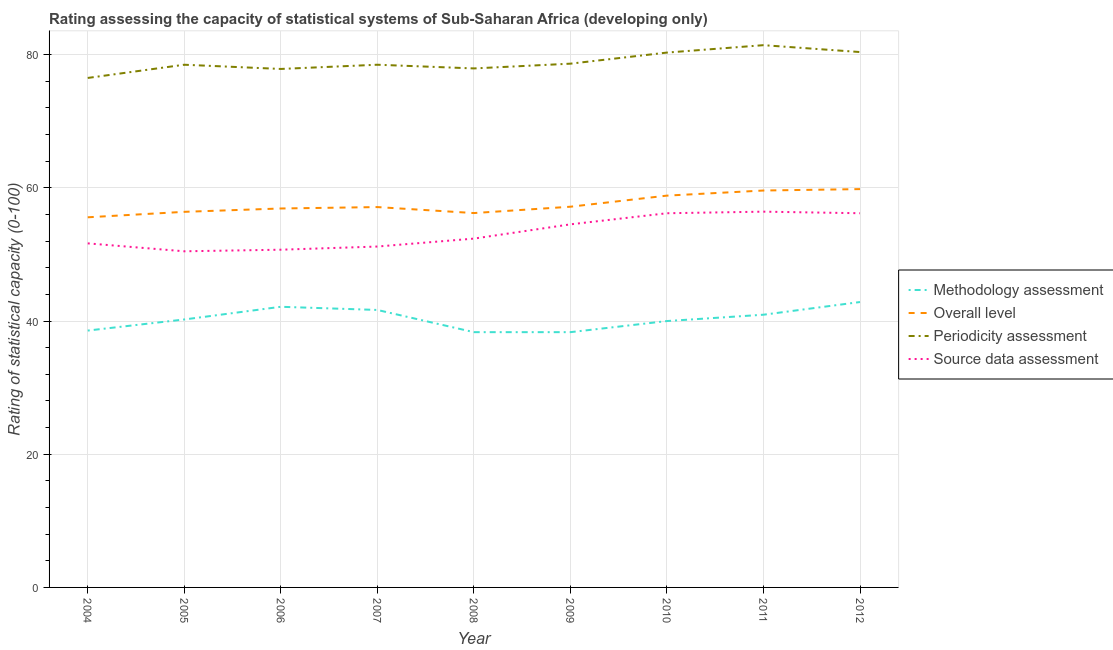How many different coloured lines are there?
Provide a succinct answer. 4. What is the periodicity assessment rating in 2009?
Keep it short and to the point. 78.65. Across all years, what is the maximum periodicity assessment rating?
Offer a very short reply. 81.43. Across all years, what is the minimum periodicity assessment rating?
Give a very brief answer. 76.51. What is the total periodicity assessment rating in the graph?
Your response must be concise. 710.08. What is the difference between the source data assessment rating in 2004 and that in 2009?
Give a very brief answer. -2.86. What is the difference between the overall level rating in 2007 and the methodology assessment rating in 2010?
Make the answer very short. 17.12. What is the average periodicity assessment rating per year?
Your answer should be compact. 78.9. In the year 2007, what is the difference between the methodology assessment rating and overall level rating?
Make the answer very short. -15.45. In how many years, is the overall level rating greater than 72?
Your answer should be very brief. 0. What is the ratio of the periodicity assessment rating in 2005 to that in 2007?
Offer a very short reply. 1. Is the source data assessment rating in 2005 less than that in 2009?
Provide a succinct answer. Yes. Is the difference between the overall level rating in 2004 and 2009 greater than the difference between the methodology assessment rating in 2004 and 2009?
Make the answer very short. No. What is the difference between the highest and the second highest overall level rating?
Offer a very short reply. 0.21. What is the difference between the highest and the lowest overall level rating?
Your response must be concise. 4.23. In how many years, is the overall level rating greater than the average overall level rating taken over all years?
Make the answer very short. 3. Is the sum of the periodicity assessment rating in 2005 and 2009 greater than the maximum overall level rating across all years?
Make the answer very short. Yes. Is it the case that in every year, the sum of the source data assessment rating and periodicity assessment rating is greater than the sum of methodology assessment rating and overall level rating?
Offer a very short reply. Yes. Is it the case that in every year, the sum of the methodology assessment rating and overall level rating is greater than the periodicity assessment rating?
Offer a terse response. Yes. Does the source data assessment rating monotonically increase over the years?
Ensure brevity in your answer.  No. Is the methodology assessment rating strictly less than the source data assessment rating over the years?
Ensure brevity in your answer.  Yes. How many years are there in the graph?
Your response must be concise. 9. What is the difference between two consecutive major ticks on the Y-axis?
Make the answer very short. 20. Does the graph contain any zero values?
Offer a very short reply. No. How many legend labels are there?
Give a very brief answer. 4. How are the legend labels stacked?
Keep it short and to the point. Vertical. What is the title of the graph?
Offer a terse response. Rating assessing the capacity of statistical systems of Sub-Saharan Africa (developing only). What is the label or title of the Y-axis?
Your response must be concise. Rating of statistical capacity (0-100). What is the Rating of statistical capacity (0-100) of Methodology assessment in 2004?
Offer a terse response. 38.57. What is the Rating of statistical capacity (0-100) in Overall level in 2004?
Offer a terse response. 55.58. What is the Rating of statistical capacity (0-100) of Periodicity assessment in 2004?
Provide a short and direct response. 76.51. What is the Rating of statistical capacity (0-100) in Source data assessment in 2004?
Provide a short and direct response. 51.67. What is the Rating of statistical capacity (0-100) of Methodology assessment in 2005?
Your response must be concise. 40.24. What is the Rating of statistical capacity (0-100) in Overall level in 2005?
Your answer should be compact. 56.4. What is the Rating of statistical capacity (0-100) in Periodicity assessment in 2005?
Offer a very short reply. 78.49. What is the Rating of statistical capacity (0-100) in Source data assessment in 2005?
Provide a succinct answer. 50.48. What is the Rating of statistical capacity (0-100) in Methodology assessment in 2006?
Provide a short and direct response. 42.14. What is the Rating of statistical capacity (0-100) of Overall level in 2006?
Make the answer very short. 56.9. What is the Rating of statistical capacity (0-100) of Periodicity assessment in 2006?
Provide a succinct answer. 77.86. What is the Rating of statistical capacity (0-100) in Source data assessment in 2006?
Offer a terse response. 50.71. What is the Rating of statistical capacity (0-100) in Methodology assessment in 2007?
Your answer should be compact. 41.67. What is the Rating of statistical capacity (0-100) of Overall level in 2007?
Provide a succinct answer. 57.12. What is the Rating of statistical capacity (0-100) in Periodicity assessment in 2007?
Your answer should be very brief. 78.49. What is the Rating of statistical capacity (0-100) in Source data assessment in 2007?
Provide a short and direct response. 51.19. What is the Rating of statistical capacity (0-100) of Methodology assessment in 2008?
Ensure brevity in your answer.  38.33. What is the Rating of statistical capacity (0-100) of Overall level in 2008?
Keep it short and to the point. 56.22. What is the Rating of statistical capacity (0-100) of Periodicity assessment in 2008?
Your answer should be compact. 77.94. What is the Rating of statistical capacity (0-100) in Source data assessment in 2008?
Your answer should be compact. 52.38. What is the Rating of statistical capacity (0-100) of Methodology assessment in 2009?
Keep it short and to the point. 38.33. What is the Rating of statistical capacity (0-100) of Overall level in 2009?
Make the answer very short. 57.17. What is the Rating of statistical capacity (0-100) of Periodicity assessment in 2009?
Your answer should be compact. 78.65. What is the Rating of statistical capacity (0-100) of Source data assessment in 2009?
Ensure brevity in your answer.  54.52. What is the Rating of statistical capacity (0-100) of Methodology assessment in 2010?
Provide a succinct answer. 40. What is the Rating of statistical capacity (0-100) of Overall level in 2010?
Provide a succinct answer. 58.84. What is the Rating of statistical capacity (0-100) of Periodicity assessment in 2010?
Provide a short and direct response. 80.32. What is the Rating of statistical capacity (0-100) in Source data assessment in 2010?
Keep it short and to the point. 56.19. What is the Rating of statistical capacity (0-100) of Methodology assessment in 2011?
Offer a very short reply. 40.95. What is the Rating of statistical capacity (0-100) of Overall level in 2011?
Keep it short and to the point. 59.6. What is the Rating of statistical capacity (0-100) in Periodicity assessment in 2011?
Give a very brief answer. 81.43. What is the Rating of statistical capacity (0-100) of Source data assessment in 2011?
Your response must be concise. 56.43. What is the Rating of statistical capacity (0-100) in Methodology assessment in 2012?
Offer a terse response. 42.86. What is the Rating of statistical capacity (0-100) of Overall level in 2012?
Provide a short and direct response. 59.81. What is the Rating of statistical capacity (0-100) of Periodicity assessment in 2012?
Keep it short and to the point. 80.4. What is the Rating of statistical capacity (0-100) in Source data assessment in 2012?
Offer a very short reply. 56.19. Across all years, what is the maximum Rating of statistical capacity (0-100) of Methodology assessment?
Offer a very short reply. 42.86. Across all years, what is the maximum Rating of statistical capacity (0-100) of Overall level?
Offer a terse response. 59.81. Across all years, what is the maximum Rating of statistical capacity (0-100) of Periodicity assessment?
Offer a terse response. 81.43. Across all years, what is the maximum Rating of statistical capacity (0-100) of Source data assessment?
Give a very brief answer. 56.43. Across all years, what is the minimum Rating of statistical capacity (0-100) in Methodology assessment?
Make the answer very short. 38.33. Across all years, what is the minimum Rating of statistical capacity (0-100) in Overall level?
Your answer should be very brief. 55.58. Across all years, what is the minimum Rating of statistical capacity (0-100) in Periodicity assessment?
Your answer should be compact. 76.51. Across all years, what is the minimum Rating of statistical capacity (0-100) in Source data assessment?
Your answer should be compact. 50.48. What is the total Rating of statistical capacity (0-100) in Methodology assessment in the graph?
Offer a terse response. 363.1. What is the total Rating of statistical capacity (0-100) in Overall level in the graph?
Provide a short and direct response. 517.65. What is the total Rating of statistical capacity (0-100) of Periodicity assessment in the graph?
Your answer should be compact. 710.08. What is the total Rating of statistical capacity (0-100) in Source data assessment in the graph?
Your response must be concise. 479.76. What is the difference between the Rating of statistical capacity (0-100) in Methodology assessment in 2004 and that in 2005?
Ensure brevity in your answer.  -1.67. What is the difference between the Rating of statistical capacity (0-100) of Overall level in 2004 and that in 2005?
Provide a short and direct response. -0.82. What is the difference between the Rating of statistical capacity (0-100) of Periodicity assessment in 2004 and that in 2005?
Provide a succinct answer. -1.98. What is the difference between the Rating of statistical capacity (0-100) in Source data assessment in 2004 and that in 2005?
Make the answer very short. 1.19. What is the difference between the Rating of statistical capacity (0-100) in Methodology assessment in 2004 and that in 2006?
Your answer should be very brief. -3.57. What is the difference between the Rating of statistical capacity (0-100) in Overall level in 2004 and that in 2006?
Your answer should be very brief. -1.32. What is the difference between the Rating of statistical capacity (0-100) in Periodicity assessment in 2004 and that in 2006?
Make the answer very short. -1.35. What is the difference between the Rating of statistical capacity (0-100) in Source data assessment in 2004 and that in 2006?
Your answer should be very brief. 0.95. What is the difference between the Rating of statistical capacity (0-100) in Methodology assessment in 2004 and that in 2007?
Give a very brief answer. -3.1. What is the difference between the Rating of statistical capacity (0-100) of Overall level in 2004 and that in 2007?
Give a very brief answer. -1.53. What is the difference between the Rating of statistical capacity (0-100) in Periodicity assessment in 2004 and that in 2007?
Provide a succinct answer. -1.98. What is the difference between the Rating of statistical capacity (0-100) of Source data assessment in 2004 and that in 2007?
Ensure brevity in your answer.  0.48. What is the difference between the Rating of statistical capacity (0-100) in Methodology assessment in 2004 and that in 2008?
Keep it short and to the point. 0.24. What is the difference between the Rating of statistical capacity (0-100) of Overall level in 2004 and that in 2008?
Make the answer very short. -0.63. What is the difference between the Rating of statistical capacity (0-100) in Periodicity assessment in 2004 and that in 2008?
Offer a very short reply. -1.43. What is the difference between the Rating of statistical capacity (0-100) in Source data assessment in 2004 and that in 2008?
Offer a terse response. -0.71. What is the difference between the Rating of statistical capacity (0-100) in Methodology assessment in 2004 and that in 2009?
Make the answer very short. 0.24. What is the difference between the Rating of statistical capacity (0-100) of Overall level in 2004 and that in 2009?
Your answer should be compact. -1.59. What is the difference between the Rating of statistical capacity (0-100) of Periodicity assessment in 2004 and that in 2009?
Your response must be concise. -2.14. What is the difference between the Rating of statistical capacity (0-100) of Source data assessment in 2004 and that in 2009?
Your answer should be compact. -2.86. What is the difference between the Rating of statistical capacity (0-100) in Methodology assessment in 2004 and that in 2010?
Make the answer very short. -1.43. What is the difference between the Rating of statistical capacity (0-100) in Overall level in 2004 and that in 2010?
Ensure brevity in your answer.  -3.25. What is the difference between the Rating of statistical capacity (0-100) in Periodicity assessment in 2004 and that in 2010?
Your answer should be very brief. -3.81. What is the difference between the Rating of statistical capacity (0-100) of Source data assessment in 2004 and that in 2010?
Offer a very short reply. -4.52. What is the difference between the Rating of statistical capacity (0-100) of Methodology assessment in 2004 and that in 2011?
Keep it short and to the point. -2.38. What is the difference between the Rating of statistical capacity (0-100) in Overall level in 2004 and that in 2011?
Ensure brevity in your answer.  -4.02. What is the difference between the Rating of statistical capacity (0-100) in Periodicity assessment in 2004 and that in 2011?
Your answer should be very brief. -4.92. What is the difference between the Rating of statistical capacity (0-100) in Source data assessment in 2004 and that in 2011?
Your answer should be compact. -4.76. What is the difference between the Rating of statistical capacity (0-100) of Methodology assessment in 2004 and that in 2012?
Provide a short and direct response. -4.29. What is the difference between the Rating of statistical capacity (0-100) of Overall level in 2004 and that in 2012?
Keep it short and to the point. -4.23. What is the difference between the Rating of statistical capacity (0-100) of Periodicity assessment in 2004 and that in 2012?
Your answer should be very brief. -3.89. What is the difference between the Rating of statistical capacity (0-100) of Source data assessment in 2004 and that in 2012?
Offer a very short reply. -4.52. What is the difference between the Rating of statistical capacity (0-100) in Methodology assessment in 2005 and that in 2006?
Ensure brevity in your answer.  -1.9. What is the difference between the Rating of statistical capacity (0-100) in Overall level in 2005 and that in 2006?
Your answer should be compact. -0.5. What is the difference between the Rating of statistical capacity (0-100) of Periodicity assessment in 2005 and that in 2006?
Provide a short and direct response. 0.63. What is the difference between the Rating of statistical capacity (0-100) of Source data assessment in 2005 and that in 2006?
Provide a short and direct response. -0.24. What is the difference between the Rating of statistical capacity (0-100) of Methodology assessment in 2005 and that in 2007?
Your answer should be very brief. -1.43. What is the difference between the Rating of statistical capacity (0-100) of Overall level in 2005 and that in 2007?
Your answer should be compact. -0.71. What is the difference between the Rating of statistical capacity (0-100) in Source data assessment in 2005 and that in 2007?
Ensure brevity in your answer.  -0.71. What is the difference between the Rating of statistical capacity (0-100) of Methodology assessment in 2005 and that in 2008?
Provide a short and direct response. 1.9. What is the difference between the Rating of statistical capacity (0-100) in Overall level in 2005 and that in 2008?
Make the answer very short. 0.19. What is the difference between the Rating of statistical capacity (0-100) of Periodicity assessment in 2005 and that in 2008?
Offer a terse response. 0.56. What is the difference between the Rating of statistical capacity (0-100) in Source data assessment in 2005 and that in 2008?
Your answer should be very brief. -1.9. What is the difference between the Rating of statistical capacity (0-100) in Methodology assessment in 2005 and that in 2009?
Provide a succinct answer. 1.9. What is the difference between the Rating of statistical capacity (0-100) of Overall level in 2005 and that in 2009?
Provide a succinct answer. -0.77. What is the difference between the Rating of statistical capacity (0-100) of Periodicity assessment in 2005 and that in 2009?
Ensure brevity in your answer.  -0.16. What is the difference between the Rating of statistical capacity (0-100) in Source data assessment in 2005 and that in 2009?
Your answer should be compact. -4.05. What is the difference between the Rating of statistical capacity (0-100) of Methodology assessment in 2005 and that in 2010?
Your answer should be very brief. 0.24. What is the difference between the Rating of statistical capacity (0-100) of Overall level in 2005 and that in 2010?
Your answer should be very brief. -2.43. What is the difference between the Rating of statistical capacity (0-100) in Periodicity assessment in 2005 and that in 2010?
Offer a very short reply. -1.83. What is the difference between the Rating of statistical capacity (0-100) in Source data assessment in 2005 and that in 2010?
Provide a short and direct response. -5.71. What is the difference between the Rating of statistical capacity (0-100) in Methodology assessment in 2005 and that in 2011?
Your answer should be very brief. -0.71. What is the difference between the Rating of statistical capacity (0-100) in Overall level in 2005 and that in 2011?
Offer a very short reply. -3.2. What is the difference between the Rating of statistical capacity (0-100) of Periodicity assessment in 2005 and that in 2011?
Give a very brief answer. -2.94. What is the difference between the Rating of statistical capacity (0-100) in Source data assessment in 2005 and that in 2011?
Provide a short and direct response. -5.95. What is the difference between the Rating of statistical capacity (0-100) of Methodology assessment in 2005 and that in 2012?
Provide a succinct answer. -2.62. What is the difference between the Rating of statistical capacity (0-100) of Overall level in 2005 and that in 2012?
Your response must be concise. -3.41. What is the difference between the Rating of statistical capacity (0-100) in Periodicity assessment in 2005 and that in 2012?
Give a very brief answer. -1.9. What is the difference between the Rating of statistical capacity (0-100) of Source data assessment in 2005 and that in 2012?
Give a very brief answer. -5.71. What is the difference between the Rating of statistical capacity (0-100) in Methodology assessment in 2006 and that in 2007?
Keep it short and to the point. 0.48. What is the difference between the Rating of statistical capacity (0-100) in Overall level in 2006 and that in 2007?
Your answer should be very brief. -0.21. What is the difference between the Rating of statistical capacity (0-100) in Periodicity assessment in 2006 and that in 2007?
Provide a succinct answer. -0.63. What is the difference between the Rating of statistical capacity (0-100) in Source data assessment in 2006 and that in 2007?
Your response must be concise. -0.48. What is the difference between the Rating of statistical capacity (0-100) in Methodology assessment in 2006 and that in 2008?
Your answer should be very brief. 3.81. What is the difference between the Rating of statistical capacity (0-100) of Overall level in 2006 and that in 2008?
Give a very brief answer. 0.69. What is the difference between the Rating of statistical capacity (0-100) in Periodicity assessment in 2006 and that in 2008?
Make the answer very short. -0.08. What is the difference between the Rating of statistical capacity (0-100) in Source data assessment in 2006 and that in 2008?
Offer a very short reply. -1.67. What is the difference between the Rating of statistical capacity (0-100) in Methodology assessment in 2006 and that in 2009?
Provide a short and direct response. 3.81. What is the difference between the Rating of statistical capacity (0-100) in Overall level in 2006 and that in 2009?
Your answer should be compact. -0.26. What is the difference between the Rating of statistical capacity (0-100) in Periodicity assessment in 2006 and that in 2009?
Make the answer very short. -0.79. What is the difference between the Rating of statistical capacity (0-100) in Source data assessment in 2006 and that in 2009?
Your response must be concise. -3.81. What is the difference between the Rating of statistical capacity (0-100) in Methodology assessment in 2006 and that in 2010?
Give a very brief answer. 2.14. What is the difference between the Rating of statistical capacity (0-100) of Overall level in 2006 and that in 2010?
Offer a very short reply. -1.93. What is the difference between the Rating of statistical capacity (0-100) in Periodicity assessment in 2006 and that in 2010?
Keep it short and to the point. -2.46. What is the difference between the Rating of statistical capacity (0-100) of Source data assessment in 2006 and that in 2010?
Offer a very short reply. -5.48. What is the difference between the Rating of statistical capacity (0-100) of Methodology assessment in 2006 and that in 2011?
Offer a terse response. 1.19. What is the difference between the Rating of statistical capacity (0-100) in Overall level in 2006 and that in 2011?
Offer a very short reply. -2.7. What is the difference between the Rating of statistical capacity (0-100) in Periodicity assessment in 2006 and that in 2011?
Ensure brevity in your answer.  -3.57. What is the difference between the Rating of statistical capacity (0-100) in Source data assessment in 2006 and that in 2011?
Make the answer very short. -5.71. What is the difference between the Rating of statistical capacity (0-100) in Methodology assessment in 2006 and that in 2012?
Your answer should be very brief. -0.71. What is the difference between the Rating of statistical capacity (0-100) of Overall level in 2006 and that in 2012?
Your answer should be very brief. -2.91. What is the difference between the Rating of statistical capacity (0-100) of Periodicity assessment in 2006 and that in 2012?
Offer a terse response. -2.54. What is the difference between the Rating of statistical capacity (0-100) of Source data assessment in 2006 and that in 2012?
Offer a very short reply. -5.48. What is the difference between the Rating of statistical capacity (0-100) of Overall level in 2007 and that in 2008?
Your answer should be very brief. 0.9. What is the difference between the Rating of statistical capacity (0-100) in Periodicity assessment in 2007 and that in 2008?
Offer a very short reply. 0.56. What is the difference between the Rating of statistical capacity (0-100) of Source data assessment in 2007 and that in 2008?
Your response must be concise. -1.19. What is the difference between the Rating of statistical capacity (0-100) in Methodology assessment in 2007 and that in 2009?
Your answer should be compact. 3.33. What is the difference between the Rating of statistical capacity (0-100) of Overall level in 2007 and that in 2009?
Make the answer very short. -0.05. What is the difference between the Rating of statistical capacity (0-100) of Periodicity assessment in 2007 and that in 2009?
Offer a terse response. -0.16. What is the difference between the Rating of statistical capacity (0-100) in Methodology assessment in 2007 and that in 2010?
Provide a short and direct response. 1.67. What is the difference between the Rating of statistical capacity (0-100) of Overall level in 2007 and that in 2010?
Keep it short and to the point. -1.72. What is the difference between the Rating of statistical capacity (0-100) of Periodicity assessment in 2007 and that in 2010?
Your answer should be very brief. -1.83. What is the difference between the Rating of statistical capacity (0-100) in Source data assessment in 2007 and that in 2010?
Keep it short and to the point. -5. What is the difference between the Rating of statistical capacity (0-100) of Overall level in 2007 and that in 2011?
Give a very brief answer. -2.49. What is the difference between the Rating of statistical capacity (0-100) in Periodicity assessment in 2007 and that in 2011?
Your answer should be very brief. -2.94. What is the difference between the Rating of statistical capacity (0-100) of Source data assessment in 2007 and that in 2011?
Keep it short and to the point. -5.24. What is the difference between the Rating of statistical capacity (0-100) of Methodology assessment in 2007 and that in 2012?
Your response must be concise. -1.19. What is the difference between the Rating of statistical capacity (0-100) in Overall level in 2007 and that in 2012?
Your response must be concise. -2.7. What is the difference between the Rating of statistical capacity (0-100) of Periodicity assessment in 2007 and that in 2012?
Offer a terse response. -1.9. What is the difference between the Rating of statistical capacity (0-100) in Source data assessment in 2007 and that in 2012?
Ensure brevity in your answer.  -5. What is the difference between the Rating of statistical capacity (0-100) in Methodology assessment in 2008 and that in 2009?
Offer a very short reply. 0. What is the difference between the Rating of statistical capacity (0-100) in Overall level in 2008 and that in 2009?
Your response must be concise. -0.95. What is the difference between the Rating of statistical capacity (0-100) of Periodicity assessment in 2008 and that in 2009?
Give a very brief answer. -0.71. What is the difference between the Rating of statistical capacity (0-100) in Source data assessment in 2008 and that in 2009?
Keep it short and to the point. -2.14. What is the difference between the Rating of statistical capacity (0-100) of Methodology assessment in 2008 and that in 2010?
Provide a short and direct response. -1.67. What is the difference between the Rating of statistical capacity (0-100) in Overall level in 2008 and that in 2010?
Offer a terse response. -2.62. What is the difference between the Rating of statistical capacity (0-100) in Periodicity assessment in 2008 and that in 2010?
Offer a terse response. -2.38. What is the difference between the Rating of statistical capacity (0-100) of Source data assessment in 2008 and that in 2010?
Make the answer very short. -3.81. What is the difference between the Rating of statistical capacity (0-100) of Methodology assessment in 2008 and that in 2011?
Your response must be concise. -2.62. What is the difference between the Rating of statistical capacity (0-100) in Overall level in 2008 and that in 2011?
Ensure brevity in your answer.  -3.39. What is the difference between the Rating of statistical capacity (0-100) in Periodicity assessment in 2008 and that in 2011?
Your response must be concise. -3.49. What is the difference between the Rating of statistical capacity (0-100) of Source data assessment in 2008 and that in 2011?
Give a very brief answer. -4.05. What is the difference between the Rating of statistical capacity (0-100) in Methodology assessment in 2008 and that in 2012?
Offer a terse response. -4.52. What is the difference between the Rating of statistical capacity (0-100) in Overall level in 2008 and that in 2012?
Your response must be concise. -3.6. What is the difference between the Rating of statistical capacity (0-100) of Periodicity assessment in 2008 and that in 2012?
Ensure brevity in your answer.  -2.46. What is the difference between the Rating of statistical capacity (0-100) in Source data assessment in 2008 and that in 2012?
Your response must be concise. -3.81. What is the difference between the Rating of statistical capacity (0-100) of Methodology assessment in 2009 and that in 2010?
Your answer should be compact. -1.67. What is the difference between the Rating of statistical capacity (0-100) in Overall level in 2009 and that in 2010?
Ensure brevity in your answer.  -1.67. What is the difference between the Rating of statistical capacity (0-100) in Periodicity assessment in 2009 and that in 2010?
Ensure brevity in your answer.  -1.67. What is the difference between the Rating of statistical capacity (0-100) of Source data assessment in 2009 and that in 2010?
Your answer should be very brief. -1.67. What is the difference between the Rating of statistical capacity (0-100) of Methodology assessment in 2009 and that in 2011?
Ensure brevity in your answer.  -2.62. What is the difference between the Rating of statistical capacity (0-100) of Overall level in 2009 and that in 2011?
Keep it short and to the point. -2.43. What is the difference between the Rating of statistical capacity (0-100) in Periodicity assessment in 2009 and that in 2011?
Offer a terse response. -2.78. What is the difference between the Rating of statistical capacity (0-100) of Source data assessment in 2009 and that in 2011?
Provide a succinct answer. -1.9. What is the difference between the Rating of statistical capacity (0-100) of Methodology assessment in 2009 and that in 2012?
Ensure brevity in your answer.  -4.52. What is the difference between the Rating of statistical capacity (0-100) of Overall level in 2009 and that in 2012?
Keep it short and to the point. -2.65. What is the difference between the Rating of statistical capacity (0-100) of Periodicity assessment in 2009 and that in 2012?
Provide a succinct answer. -1.75. What is the difference between the Rating of statistical capacity (0-100) of Source data assessment in 2009 and that in 2012?
Your answer should be compact. -1.67. What is the difference between the Rating of statistical capacity (0-100) of Methodology assessment in 2010 and that in 2011?
Give a very brief answer. -0.95. What is the difference between the Rating of statistical capacity (0-100) in Overall level in 2010 and that in 2011?
Offer a very short reply. -0.77. What is the difference between the Rating of statistical capacity (0-100) in Periodicity assessment in 2010 and that in 2011?
Your answer should be very brief. -1.11. What is the difference between the Rating of statistical capacity (0-100) of Source data assessment in 2010 and that in 2011?
Provide a succinct answer. -0.24. What is the difference between the Rating of statistical capacity (0-100) of Methodology assessment in 2010 and that in 2012?
Make the answer very short. -2.86. What is the difference between the Rating of statistical capacity (0-100) in Overall level in 2010 and that in 2012?
Your response must be concise. -0.98. What is the difference between the Rating of statistical capacity (0-100) in Periodicity assessment in 2010 and that in 2012?
Provide a succinct answer. -0.08. What is the difference between the Rating of statistical capacity (0-100) in Methodology assessment in 2011 and that in 2012?
Your response must be concise. -1.9. What is the difference between the Rating of statistical capacity (0-100) in Overall level in 2011 and that in 2012?
Provide a short and direct response. -0.21. What is the difference between the Rating of statistical capacity (0-100) in Periodicity assessment in 2011 and that in 2012?
Your answer should be compact. 1.03. What is the difference between the Rating of statistical capacity (0-100) of Source data assessment in 2011 and that in 2012?
Offer a terse response. 0.24. What is the difference between the Rating of statistical capacity (0-100) of Methodology assessment in 2004 and the Rating of statistical capacity (0-100) of Overall level in 2005?
Provide a succinct answer. -17.83. What is the difference between the Rating of statistical capacity (0-100) of Methodology assessment in 2004 and the Rating of statistical capacity (0-100) of Periodicity assessment in 2005?
Your answer should be very brief. -39.92. What is the difference between the Rating of statistical capacity (0-100) of Methodology assessment in 2004 and the Rating of statistical capacity (0-100) of Source data assessment in 2005?
Ensure brevity in your answer.  -11.9. What is the difference between the Rating of statistical capacity (0-100) in Overall level in 2004 and the Rating of statistical capacity (0-100) in Periodicity assessment in 2005?
Offer a very short reply. -22.91. What is the difference between the Rating of statistical capacity (0-100) of Overall level in 2004 and the Rating of statistical capacity (0-100) of Source data assessment in 2005?
Provide a succinct answer. 5.11. What is the difference between the Rating of statistical capacity (0-100) in Periodicity assessment in 2004 and the Rating of statistical capacity (0-100) in Source data assessment in 2005?
Offer a very short reply. 26.03. What is the difference between the Rating of statistical capacity (0-100) in Methodology assessment in 2004 and the Rating of statistical capacity (0-100) in Overall level in 2006?
Make the answer very short. -18.33. What is the difference between the Rating of statistical capacity (0-100) in Methodology assessment in 2004 and the Rating of statistical capacity (0-100) in Periodicity assessment in 2006?
Keep it short and to the point. -39.29. What is the difference between the Rating of statistical capacity (0-100) of Methodology assessment in 2004 and the Rating of statistical capacity (0-100) of Source data assessment in 2006?
Offer a terse response. -12.14. What is the difference between the Rating of statistical capacity (0-100) of Overall level in 2004 and the Rating of statistical capacity (0-100) of Periodicity assessment in 2006?
Keep it short and to the point. -22.28. What is the difference between the Rating of statistical capacity (0-100) in Overall level in 2004 and the Rating of statistical capacity (0-100) in Source data assessment in 2006?
Keep it short and to the point. 4.87. What is the difference between the Rating of statistical capacity (0-100) of Periodicity assessment in 2004 and the Rating of statistical capacity (0-100) of Source data assessment in 2006?
Keep it short and to the point. 25.79. What is the difference between the Rating of statistical capacity (0-100) in Methodology assessment in 2004 and the Rating of statistical capacity (0-100) in Overall level in 2007?
Make the answer very short. -18.55. What is the difference between the Rating of statistical capacity (0-100) of Methodology assessment in 2004 and the Rating of statistical capacity (0-100) of Periodicity assessment in 2007?
Keep it short and to the point. -39.92. What is the difference between the Rating of statistical capacity (0-100) in Methodology assessment in 2004 and the Rating of statistical capacity (0-100) in Source data assessment in 2007?
Ensure brevity in your answer.  -12.62. What is the difference between the Rating of statistical capacity (0-100) of Overall level in 2004 and the Rating of statistical capacity (0-100) of Periodicity assessment in 2007?
Your response must be concise. -22.91. What is the difference between the Rating of statistical capacity (0-100) in Overall level in 2004 and the Rating of statistical capacity (0-100) in Source data assessment in 2007?
Your answer should be compact. 4.39. What is the difference between the Rating of statistical capacity (0-100) of Periodicity assessment in 2004 and the Rating of statistical capacity (0-100) of Source data assessment in 2007?
Provide a succinct answer. 25.32. What is the difference between the Rating of statistical capacity (0-100) in Methodology assessment in 2004 and the Rating of statistical capacity (0-100) in Overall level in 2008?
Give a very brief answer. -17.65. What is the difference between the Rating of statistical capacity (0-100) of Methodology assessment in 2004 and the Rating of statistical capacity (0-100) of Periodicity assessment in 2008?
Your response must be concise. -39.37. What is the difference between the Rating of statistical capacity (0-100) in Methodology assessment in 2004 and the Rating of statistical capacity (0-100) in Source data assessment in 2008?
Offer a terse response. -13.81. What is the difference between the Rating of statistical capacity (0-100) of Overall level in 2004 and the Rating of statistical capacity (0-100) of Periodicity assessment in 2008?
Your response must be concise. -22.35. What is the difference between the Rating of statistical capacity (0-100) of Overall level in 2004 and the Rating of statistical capacity (0-100) of Source data assessment in 2008?
Provide a short and direct response. 3.2. What is the difference between the Rating of statistical capacity (0-100) of Periodicity assessment in 2004 and the Rating of statistical capacity (0-100) of Source data assessment in 2008?
Offer a very short reply. 24.13. What is the difference between the Rating of statistical capacity (0-100) of Methodology assessment in 2004 and the Rating of statistical capacity (0-100) of Overall level in 2009?
Keep it short and to the point. -18.6. What is the difference between the Rating of statistical capacity (0-100) in Methodology assessment in 2004 and the Rating of statistical capacity (0-100) in Periodicity assessment in 2009?
Your answer should be very brief. -40.08. What is the difference between the Rating of statistical capacity (0-100) of Methodology assessment in 2004 and the Rating of statistical capacity (0-100) of Source data assessment in 2009?
Give a very brief answer. -15.95. What is the difference between the Rating of statistical capacity (0-100) of Overall level in 2004 and the Rating of statistical capacity (0-100) of Periodicity assessment in 2009?
Offer a very short reply. -23.07. What is the difference between the Rating of statistical capacity (0-100) in Overall level in 2004 and the Rating of statistical capacity (0-100) in Source data assessment in 2009?
Offer a very short reply. 1.06. What is the difference between the Rating of statistical capacity (0-100) in Periodicity assessment in 2004 and the Rating of statistical capacity (0-100) in Source data assessment in 2009?
Provide a succinct answer. 21.98. What is the difference between the Rating of statistical capacity (0-100) of Methodology assessment in 2004 and the Rating of statistical capacity (0-100) of Overall level in 2010?
Your response must be concise. -20.26. What is the difference between the Rating of statistical capacity (0-100) of Methodology assessment in 2004 and the Rating of statistical capacity (0-100) of Periodicity assessment in 2010?
Offer a terse response. -41.75. What is the difference between the Rating of statistical capacity (0-100) in Methodology assessment in 2004 and the Rating of statistical capacity (0-100) in Source data assessment in 2010?
Make the answer very short. -17.62. What is the difference between the Rating of statistical capacity (0-100) of Overall level in 2004 and the Rating of statistical capacity (0-100) of Periodicity assessment in 2010?
Keep it short and to the point. -24.74. What is the difference between the Rating of statistical capacity (0-100) of Overall level in 2004 and the Rating of statistical capacity (0-100) of Source data assessment in 2010?
Offer a very short reply. -0.61. What is the difference between the Rating of statistical capacity (0-100) of Periodicity assessment in 2004 and the Rating of statistical capacity (0-100) of Source data assessment in 2010?
Your answer should be compact. 20.32. What is the difference between the Rating of statistical capacity (0-100) in Methodology assessment in 2004 and the Rating of statistical capacity (0-100) in Overall level in 2011?
Make the answer very short. -21.03. What is the difference between the Rating of statistical capacity (0-100) in Methodology assessment in 2004 and the Rating of statistical capacity (0-100) in Periodicity assessment in 2011?
Your answer should be compact. -42.86. What is the difference between the Rating of statistical capacity (0-100) in Methodology assessment in 2004 and the Rating of statistical capacity (0-100) in Source data assessment in 2011?
Provide a succinct answer. -17.86. What is the difference between the Rating of statistical capacity (0-100) of Overall level in 2004 and the Rating of statistical capacity (0-100) of Periodicity assessment in 2011?
Your answer should be compact. -25.85. What is the difference between the Rating of statistical capacity (0-100) in Overall level in 2004 and the Rating of statistical capacity (0-100) in Source data assessment in 2011?
Offer a terse response. -0.85. What is the difference between the Rating of statistical capacity (0-100) of Periodicity assessment in 2004 and the Rating of statistical capacity (0-100) of Source data assessment in 2011?
Your response must be concise. 20.08. What is the difference between the Rating of statistical capacity (0-100) of Methodology assessment in 2004 and the Rating of statistical capacity (0-100) of Overall level in 2012?
Your response must be concise. -21.24. What is the difference between the Rating of statistical capacity (0-100) of Methodology assessment in 2004 and the Rating of statistical capacity (0-100) of Periodicity assessment in 2012?
Provide a short and direct response. -41.83. What is the difference between the Rating of statistical capacity (0-100) of Methodology assessment in 2004 and the Rating of statistical capacity (0-100) of Source data assessment in 2012?
Ensure brevity in your answer.  -17.62. What is the difference between the Rating of statistical capacity (0-100) in Overall level in 2004 and the Rating of statistical capacity (0-100) in Periodicity assessment in 2012?
Provide a succinct answer. -24.81. What is the difference between the Rating of statistical capacity (0-100) of Overall level in 2004 and the Rating of statistical capacity (0-100) of Source data assessment in 2012?
Provide a short and direct response. -0.61. What is the difference between the Rating of statistical capacity (0-100) of Periodicity assessment in 2004 and the Rating of statistical capacity (0-100) of Source data assessment in 2012?
Give a very brief answer. 20.32. What is the difference between the Rating of statistical capacity (0-100) in Methodology assessment in 2005 and the Rating of statistical capacity (0-100) in Overall level in 2006?
Provide a succinct answer. -16.67. What is the difference between the Rating of statistical capacity (0-100) of Methodology assessment in 2005 and the Rating of statistical capacity (0-100) of Periodicity assessment in 2006?
Your response must be concise. -37.62. What is the difference between the Rating of statistical capacity (0-100) in Methodology assessment in 2005 and the Rating of statistical capacity (0-100) in Source data assessment in 2006?
Offer a very short reply. -10.48. What is the difference between the Rating of statistical capacity (0-100) in Overall level in 2005 and the Rating of statistical capacity (0-100) in Periodicity assessment in 2006?
Provide a succinct answer. -21.45. What is the difference between the Rating of statistical capacity (0-100) of Overall level in 2005 and the Rating of statistical capacity (0-100) of Source data assessment in 2006?
Ensure brevity in your answer.  5.69. What is the difference between the Rating of statistical capacity (0-100) in Periodicity assessment in 2005 and the Rating of statistical capacity (0-100) in Source data assessment in 2006?
Offer a terse response. 27.78. What is the difference between the Rating of statistical capacity (0-100) in Methodology assessment in 2005 and the Rating of statistical capacity (0-100) in Overall level in 2007?
Provide a succinct answer. -16.88. What is the difference between the Rating of statistical capacity (0-100) in Methodology assessment in 2005 and the Rating of statistical capacity (0-100) in Periodicity assessment in 2007?
Give a very brief answer. -38.25. What is the difference between the Rating of statistical capacity (0-100) of Methodology assessment in 2005 and the Rating of statistical capacity (0-100) of Source data assessment in 2007?
Your response must be concise. -10.95. What is the difference between the Rating of statistical capacity (0-100) in Overall level in 2005 and the Rating of statistical capacity (0-100) in Periodicity assessment in 2007?
Provide a short and direct response. -22.09. What is the difference between the Rating of statistical capacity (0-100) in Overall level in 2005 and the Rating of statistical capacity (0-100) in Source data assessment in 2007?
Provide a succinct answer. 5.21. What is the difference between the Rating of statistical capacity (0-100) of Periodicity assessment in 2005 and the Rating of statistical capacity (0-100) of Source data assessment in 2007?
Give a very brief answer. 27.3. What is the difference between the Rating of statistical capacity (0-100) of Methodology assessment in 2005 and the Rating of statistical capacity (0-100) of Overall level in 2008?
Your answer should be very brief. -15.98. What is the difference between the Rating of statistical capacity (0-100) in Methodology assessment in 2005 and the Rating of statistical capacity (0-100) in Periodicity assessment in 2008?
Offer a terse response. -37.7. What is the difference between the Rating of statistical capacity (0-100) of Methodology assessment in 2005 and the Rating of statistical capacity (0-100) of Source data assessment in 2008?
Keep it short and to the point. -12.14. What is the difference between the Rating of statistical capacity (0-100) of Overall level in 2005 and the Rating of statistical capacity (0-100) of Periodicity assessment in 2008?
Your response must be concise. -21.53. What is the difference between the Rating of statistical capacity (0-100) in Overall level in 2005 and the Rating of statistical capacity (0-100) in Source data assessment in 2008?
Your answer should be very brief. 4.02. What is the difference between the Rating of statistical capacity (0-100) of Periodicity assessment in 2005 and the Rating of statistical capacity (0-100) of Source data assessment in 2008?
Keep it short and to the point. 26.11. What is the difference between the Rating of statistical capacity (0-100) in Methodology assessment in 2005 and the Rating of statistical capacity (0-100) in Overall level in 2009?
Your response must be concise. -16.93. What is the difference between the Rating of statistical capacity (0-100) of Methodology assessment in 2005 and the Rating of statistical capacity (0-100) of Periodicity assessment in 2009?
Offer a terse response. -38.41. What is the difference between the Rating of statistical capacity (0-100) in Methodology assessment in 2005 and the Rating of statistical capacity (0-100) in Source data assessment in 2009?
Keep it short and to the point. -14.29. What is the difference between the Rating of statistical capacity (0-100) of Overall level in 2005 and the Rating of statistical capacity (0-100) of Periodicity assessment in 2009?
Keep it short and to the point. -22.25. What is the difference between the Rating of statistical capacity (0-100) of Overall level in 2005 and the Rating of statistical capacity (0-100) of Source data assessment in 2009?
Give a very brief answer. 1.88. What is the difference between the Rating of statistical capacity (0-100) in Periodicity assessment in 2005 and the Rating of statistical capacity (0-100) in Source data assessment in 2009?
Provide a short and direct response. 23.97. What is the difference between the Rating of statistical capacity (0-100) of Methodology assessment in 2005 and the Rating of statistical capacity (0-100) of Overall level in 2010?
Ensure brevity in your answer.  -18.6. What is the difference between the Rating of statistical capacity (0-100) of Methodology assessment in 2005 and the Rating of statistical capacity (0-100) of Periodicity assessment in 2010?
Ensure brevity in your answer.  -40.08. What is the difference between the Rating of statistical capacity (0-100) in Methodology assessment in 2005 and the Rating of statistical capacity (0-100) in Source data assessment in 2010?
Your answer should be very brief. -15.95. What is the difference between the Rating of statistical capacity (0-100) in Overall level in 2005 and the Rating of statistical capacity (0-100) in Periodicity assessment in 2010?
Your answer should be compact. -23.92. What is the difference between the Rating of statistical capacity (0-100) of Overall level in 2005 and the Rating of statistical capacity (0-100) of Source data assessment in 2010?
Provide a short and direct response. 0.21. What is the difference between the Rating of statistical capacity (0-100) of Periodicity assessment in 2005 and the Rating of statistical capacity (0-100) of Source data assessment in 2010?
Keep it short and to the point. 22.3. What is the difference between the Rating of statistical capacity (0-100) in Methodology assessment in 2005 and the Rating of statistical capacity (0-100) in Overall level in 2011?
Your answer should be compact. -19.37. What is the difference between the Rating of statistical capacity (0-100) in Methodology assessment in 2005 and the Rating of statistical capacity (0-100) in Periodicity assessment in 2011?
Your answer should be very brief. -41.19. What is the difference between the Rating of statistical capacity (0-100) in Methodology assessment in 2005 and the Rating of statistical capacity (0-100) in Source data assessment in 2011?
Give a very brief answer. -16.19. What is the difference between the Rating of statistical capacity (0-100) in Overall level in 2005 and the Rating of statistical capacity (0-100) in Periodicity assessment in 2011?
Your response must be concise. -25.03. What is the difference between the Rating of statistical capacity (0-100) in Overall level in 2005 and the Rating of statistical capacity (0-100) in Source data assessment in 2011?
Your answer should be compact. -0.03. What is the difference between the Rating of statistical capacity (0-100) of Periodicity assessment in 2005 and the Rating of statistical capacity (0-100) of Source data assessment in 2011?
Provide a succinct answer. 22.06. What is the difference between the Rating of statistical capacity (0-100) of Methodology assessment in 2005 and the Rating of statistical capacity (0-100) of Overall level in 2012?
Provide a succinct answer. -19.58. What is the difference between the Rating of statistical capacity (0-100) of Methodology assessment in 2005 and the Rating of statistical capacity (0-100) of Periodicity assessment in 2012?
Provide a succinct answer. -40.16. What is the difference between the Rating of statistical capacity (0-100) of Methodology assessment in 2005 and the Rating of statistical capacity (0-100) of Source data assessment in 2012?
Give a very brief answer. -15.95. What is the difference between the Rating of statistical capacity (0-100) of Overall level in 2005 and the Rating of statistical capacity (0-100) of Periodicity assessment in 2012?
Ensure brevity in your answer.  -23.99. What is the difference between the Rating of statistical capacity (0-100) of Overall level in 2005 and the Rating of statistical capacity (0-100) of Source data assessment in 2012?
Offer a very short reply. 0.21. What is the difference between the Rating of statistical capacity (0-100) in Periodicity assessment in 2005 and the Rating of statistical capacity (0-100) in Source data assessment in 2012?
Offer a terse response. 22.3. What is the difference between the Rating of statistical capacity (0-100) in Methodology assessment in 2006 and the Rating of statistical capacity (0-100) in Overall level in 2007?
Offer a very short reply. -14.97. What is the difference between the Rating of statistical capacity (0-100) in Methodology assessment in 2006 and the Rating of statistical capacity (0-100) in Periodicity assessment in 2007?
Keep it short and to the point. -36.35. What is the difference between the Rating of statistical capacity (0-100) in Methodology assessment in 2006 and the Rating of statistical capacity (0-100) in Source data assessment in 2007?
Offer a very short reply. -9.05. What is the difference between the Rating of statistical capacity (0-100) in Overall level in 2006 and the Rating of statistical capacity (0-100) in Periodicity assessment in 2007?
Make the answer very short. -21.59. What is the difference between the Rating of statistical capacity (0-100) of Overall level in 2006 and the Rating of statistical capacity (0-100) of Source data assessment in 2007?
Offer a very short reply. 5.71. What is the difference between the Rating of statistical capacity (0-100) of Periodicity assessment in 2006 and the Rating of statistical capacity (0-100) of Source data assessment in 2007?
Ensure brevity in your answer.  26.67. What is the difference between the Rating of statistical capacity (0-100) in Methodology assessment in 2006 and the Rating of statistical capacity (0-100) in Overall level in 2008?
Offer a very short reply. -14.07. What is the difference between the Rating of statistical capacity (0-100) of Methodology assessment in 2006 and the Rating of statistical capacity (0-100) of Periodicity assessment in 2008?
Offer a terse response. -35.79. What is the difference between the Rating of statistical capacity (0-100) of Methodology assessment in 2006 and the Rating of statistical capacity (0-100) of Source data assessment in 2008?
Give a very brief answer. -10.24. What is the difference between the Rating of statistical capacity (0-100) of Overall level in 2006 and the Rating of statistical capacity (0-100) of Periodicity assessment in 2008?
Offer a very short reply. -21.03. What is the difference between the Rating of statistical capacity (0-100) in Overall level in 2006 and the Rating of statistical capacity (0-100) in Source data assessment in 2008?
Provide a short and direct response. 4.52. What is the difference between the Rating of statistical capacity (0-100) of Periodicity assessment in 2006 and the Rating of statistical capacity (0-100) of Source data assessment in 2008?
Give a very brief answer. 25.48. What is the difference between the Rating of statistical capacity (0-100) of Methodology assessment in 2006 and the Rating of statistical capacity (0-100) of Overall level in 2009?
Offer a very short reply. -15.03. What is the difference between the Rating of statistical capacity (0-100) in Methodology assessment in 2006 and the Rating of statistical capacity (0-100) in Periodicity assessment in 2009?
Your response must be concise. -36.51. What is the difference between the Rating of statistical capacity (0-100) of Methodology assessment in 2006 and the Rating of statistical capacity (0-100) of Source data assessment in 2009?
Your answer should be compact. -12.38. What is the difference between the Rating of statistical capacity (0-100) of Overall level in 2006 and the Rating of statistical capacity (0-100) of Periodicity assessment in 2009?
Make the answer very short. -21.75. What is the difference between the Rating of statistical capacity (0-100) of Overall level in 2006 and the Rating of statistical capacity (0-100) of Source data assessment in 2009?
Your response must be concise. 2.38. What is the difference between the Rating of statistical capacity (0-100) in Periodicity assessment in 2006 and the Rating of statistical capacity (0-100) in Source data assessment in 2009?
Provide a succinct answer. 23.33. What is the difference between the Rating of statistical capacity (0-100) in Methodology assessment in 2006 and the Rating of statistical capacity (0-100) in Overall level in 2010?
Offer a very short reply. -16.69. What is the difference between the Rating of statistical capacity (0-100) in Methodology assessment in 2006 and the Rating of statistical capacity (0-100) in Periodicity assessment in 2010?
Ensure brevity in your answer.  -38.17. What is the difference between the Rating of statistical capacity (0-100) of Methodology assessment in 2006 and the Rating of statistical capacity (0-100) of Source data assessment in 2010?
Your answer should be compact. -14.05. What is the difference between the Rating of statistical capacity (0-100) in Overall level in 2006 and the Rating of statistical capacity (0-100) in Periodicity assessment in 2010?
Your answer should be very brief. -23.41. What is the difference between the Rating of statistical capacity (0-100) of Periodicity assessment in 2006 and the Rating of statistical capacity (0-100) of Source data assessment in 2010?
Offer a very short reply. 21.67. What is the difference between the Rating of statistical capacity (0-100) of Methodology assessment in 2006 and the Rating of statistical capacity (0-100) of Overall level in 2011?
Give a very brief answer. -17.46. What is the difference between the Rating of statistical capacity (0-100) of Methodology assessment in 2006 and the Rating of statistical capacity (0-100) of Periodicity assessment in 2011?
Offer a terse response. -39.29. What is the difference between the Rating of statistical capacity (0-100) in Methodology assessment in 2006 and the Rating of statistical capacity (0-100) in Source data assessment in 2011?
Your answer should be very brief. -14.29. What is the difference between the Rating of statistical capacity (0-100) of Overall level in 2006 and the Rating of statistical capacity (0-100) of Periodicity assessment in 2011?
Your answer should be very brief. -24.52. What is the difference between the Rating of statistical capacity (0-100) in Overall level in 2006 and the Rating of statistical capacity (0-100) in Source data assessment in 2011?
Your answer should be compact. 0.48. What is the difference between the Rating of statistical capacity (0-100) in Periodicity assessment in 2006 and the Rating of statistical capacity (0-100) in Source data assessment in 2011?
Offer a very short reply. 21.43. What is the difference between the Rating of statistical capacity (0-100) of Methodology assessment in 2006 and the Rating of statistical capacity (0-100) of Overall level in 2012?
Your answer should be very brief. -17.67. What is the difference between the Rating of statistical capacity (0-100) in Methodology assessment in 2006 and the Rating of statistical capacity (0-100) in Periodicity assessment in 2012?
Keep it short and to the point. -38.25. What is the difference between the Rating of statistical capacity (0-100) in Methodology assessment in 2006 and the Rating of statistical capacity (0-100) in Source data assessment in 2012?
Keep it short and to the point. -14.05. What is the difference between the Rating of statistical capacity (0-100) in Overall level in 2006 and the Rating of statistical capacity (0-100) in Periodicity assessment in 2012?
Give a very brief answer. -23.49. What is the difference between the Rating of statistical capacity (0-100) in Overall level in 2006 and the Rating of statistical capacity (0-100) in Source data assessment in 2012?
Ensure brevity in your answer.  0.71. What is the difference between the Rating of statistical capacity (0-100) of Periodicity assessment in 2006 and the Rating of statistical capacity (0-100) of Source data assessment in 2012?
Provide a short and direct response. 21.67. What is the difference between the Rating of statistical capacity (0-100) in Methodology assessment in 2007 and the Rating of statistical capacity (0-100) in Overall level in 2008?
Give a very brief answer. -14.55. What is the difference between the Rating of statistical capacity (0-100) of Methodology assessment in 2007 and the Rating of statistical capacity (0-100) of Periodicity assessment in 2008?
Offer a terse response. -36.27. What is the difference between the Rating of statistical capacity (0-100) in Methodology assessment in 2007 and the Rating of statistical capacity (0-100) in Source data assessment in 2008?
Ensure brevity in your answer.  -10.71. What is the difference between the Rating of statistical capacity (0-100) in Overall level in 2007 and the Rating of statistical capacity (0-100) in Periodicity assessment in 2008?
Your answer should be compact. -20.82. What is the difference between the Rating of statistical capacity (0-100) of Overall level in 2007 and the Rating of statistical capacity (0-100) of Source data assessment in 2008?
Your answer should be compact. 4.74. What is the difference between the Rating of statistical capacity (0-100) of Periodicity assessment in 2007 and the Rating of statistical capacity (0-100) of Source data assessment in 2008?
Provide a short and direct response. 26.11. What is the difference between the Rating of statistical capacity (0-100) of Methodology assessment in 2007 and the Rating of statistical capacity (0-100) of Overall level in 2009?
Your response must be concise. -15.5. What is the difference between the Rating of statistical capacity (0-100) of Methodology assessment in 2007 and the Rating of statistical capacity (0-100) of Periodicity assessment in 2009?
Offer a very short reply. -36.98. What is the difference between the Rating of statistical capacity (0-100) of Methodology assessment in 2007 and the Rating of statistical capacity (0-100) of Source data assessment in 2009?
Provide a succinct answer. -12.86. What is the difference between the Rating of statistical capacity (0-100) in Overall level in 2007 and the Rating of statistical capacity (0-100) in Periodicity assessment in 2009?
Ensure brevity in your answer.  -21.53. What is the difference between the Rating of statistical capacity (0-100) in Overall level in 2007 and the Rating of statistical capacity (0-100) in Source data assessment in 2009?
Make the answer very short. 2.59. What is the difference between the Rating of statistical capacity (0-100) in Periodicity assessment in 2007 and the Rating of statistical capacity (0-100) in Source data assessment in 2009?
Your answer should be very brief. 23.97. What is the difference between the Rating of statistical capacity (0-100) of Methodology assessment in 2007 and the Rating of statistical capacity (0-100) of Overall level in 2010?
Keep it short and to the point. -17.17. What is the difference between the Rating of statistical capacity (0-100) of Methodology assessment in 2007 and the Rating of statistical capacity (0-100) of Periodicity assessment in 2010?
Ensure brevity in your answer.  -38.65. What is the difference between the Rating of statistical capacity (0-100) of Methodology assessment in 2007 and the Rating of statistical capacity (0-100) of Source data assessment in 2010?
Provide a succinct answer. -14.52. What is the difference between the Rating of statistical capacity (0-100) of Overall level in 2007 and the Rating of statistical capacity (0-100) of Periodicity assessment in 2010?
Provide a short and direct response. -23.2. What is the difference between the Rating of statistical capacity (0-100) in Overall level in 2007 and the Rating of statistical capacity (0-100) in Source data assessment in 2010?
Keep it short and to the point. 0.93. What is the difference between the Rating of statistical capacity (0-100) in Periodicity assessment in 2007 and the Rating of statistical capacity (0-100) in Source data assessment in 2010?
Give a very brief answer. 22.3. What is the difference between the Rating of statistical capacity (0-100) in Methodology assessment in 2007 and the Rating of statistical capacity (0-100) in Overall level in 2011?
Provide a short and direct response. -17.94. What is the difference between the Rating of statistical capacity (0-100) of Methodology assessment in 2007 and the Rating of statistical capacity (0-100) of Periodicity assessment in 2011?
Provide a short and direct response. -39.76. What is the difference between the Rating of statistical capacity (0-100) of Methodology assessment in 2007 and the Rating of statistical capacity (0-100) of Source data assessment in 2011?
Provide a short and direct response. -14.76. What is the difference between the Rating of statistical capacity (0-100) in Overall level in 2007 and the Rating of statistical capacity (0-100) in Periodicity assessment in 2011?
Ensure brevity in your answer.  -24.31. What is the difference between the Rating of statistical capacity (0-100) of Overall level in 2007 and the Rating of statistical capacity (0-100) of Source data assessment in 2011?
Your response must be concise. 0.69. What is the difference between the Rating of statistical capacity (0-100) of Periodicity assessment in 2007 and the Rating of statistical capacity (0-100) of Source data assessment in 2011?
Keep it short and to the point. 22.06. What is the difference between the Rating of statistical capacity (0-100) of Methodology assessment in 2007 and the Rating of statistical capacity (0-100) of Overall level in 2012?
Ensure brevity in your answer.  -18.15. What is the difference between the Rating of statistical capacity (0-100) in Methodology assessment in 2007 and the Rating of statistical capacity (0-100) in Periodicity assessment in 2012?
Your response must be concise. -38.73. What is the difference between the Rating of statistical capacity (0-100) of Methodology assessment in 2007 and the Rating of statistical capacity (0-100) of Source data assessment in 2012?
Your response must be concise. -14.52. What is the difference between the Rating of statistical capacity (0-100) of Overall level in 2007 and the Rating of statistical capacity (0-100) of Periodicity assessment in 2012?
Your answer should be very brief. -23.28. What is the difference between the Rating of statistical capacity (0-100) in Overall level in 2007 and the Rating of statistical capacity (0-100) in Source data assessment in 2012?
Offer a terse response. 0.93. What is the difference between the Rating of statistical capacity (0-100) in Periodicity assessment in 2007 and the Rating of statistical capacity (0-100) in Source data assessment in 2012?
Keep it short and to the point. 22.3. What is the difference between the Rating of statistical capacity (0-100) of Methodology assessment in 2008 and the Rating of statistical capacity (0-100) of Overall level in 2009?
Give a very brief answer. -18.84. What is the difference between the Rating of statistical capacity (0-100) in Methodology assessment in 2008 and the Rating of statistical capacity (0-100) in Periodicity assessment in 2009?
Your answer should be very brief. -40.32. What is the difference between the Rating of statistical capacity (0-100) in Methodology assessment in 2008 and the Rating of statistical capacity (0-100) in Source data assessment in 2009?
Make the answer very short. -16.19. What is the difference between the Rating of statistical capacity (0-100) of Overall level in 2008 and the Rating of statistical capacity (0-100) of Periodicity assessment in 2009?
Give a very brief answer. -22.43. What is the difference between the Rating of statistical capacity (0-100) of Overall level in 2008 and the Rating of statistical capacity (0-100) of Source data assessment in 2009?
Offer a very short reply. 1.69. What is the difference between the Rating of statistical capacity (0-100) of Periodicity assessment in 2008 and the Rating of statistical capacity (0-100) of Source data assessment in 2009?
Your answer should be very brief. 23.41. What is the difference between the Rating of statistical capacity (0-100) in Methodology assessment in 2008 and the Rating of statistical capacity (0-100) in Overall level in 2010?
Ensure brevity in your answer.  -20.5. What is the difference between the Rating of statistical capacity (0-100) in Methodology assessment in 2008 and the Rating of statistical capacity (0-100) in Periodicity assessment in 2010?
Your answer should be compact. -41.98. What is the difference between the Rating of statistical capacity (0-100) of Methodology assessment in 2008 and the Rating of statistical capacity (0-100) of Source data assessment in 2010?
Provide a succinct answer. -17.86. What is the difference between the Rating of statistical capacity (0-100) in Overall level in 2008 and the Rating of statistical capacity (0-100) in Periodicity assessment in 2010?
Your answer should be compact. -24.1. What is the difference between the Rating of statistical capacity (0-100) of Overall level in 2008 and the Rating of statistical capacity (0-100) of Source data assessment in 2010?
Offer a terse response. 0.03. What is the difference between the Rating of statistical capacity (0-100) of Periodicity assessment in 2008 and the Rating of statistical capacity (0-100) of Source data assessment in 2010?
Offer a terse response. 21.75. What is the difference between the Rating of statistical capacity (0-100) of Methodology assessment in 2008 and the Rating of statistical capacity (0-100) of Overall level in 2011?
Your response must be concise. -21.27. What is the difference between the Rating of statistical capacity (0-100) of Methodology assessment in 2008 and the Rating of statistical capacity (0-100) of Periodicity assessment in 2011?
Provide a short and direct response. -43.1. What is the difference between the Rating of statistical capacity (0-100) of Methodology assessment in 2008 and the Rating of statistical capacity (0-100) of Source data assessment in 2011?
Your response must be concise. -18.1. What is the difference between the Rating of statistical capacity (0-100) in Overall level in 2008 and the Rating of statistical capacity (0-100) in Periodicity assessment in 2011?
Your answer should be very brief. -25.21. What is the difference between the Rating of statistical capacity (0-100) of Overall level in 2008 and the Rating of statistical capacity (0-100) of Source data assessment in 2011?
Provide a short and direct response. -0.21. What is the difference between the Rating of statistical capacity (0-100) in Periodicity assessment in 2008 and the Rating of statistical capacity (0-100) in Source data assessment in 2011?
Offer a very short reply. 21.51. What is the difference between the Rating of statistical capacity (0-100) in Methodology assessment in 2008 and the Rating of statistical capacity (0-100) in Overall level in 2012?
Provide a short and direct response. -21.48. What is the difference between the Rating of statistical capacity (0-100) of Methodology assessment in 2008 and the Rating of statistical capacity (0-100) of Periodicity assessment in 2012?
Offer a very short reply. -42.06. What is the difference between the Rating of statistical capacity (0-100) in Methodology assessment in 2008 and the Rating of statistical capacity (0-100) in Source data assessment in 2012?
Make the answer very short. -17.86. What is the difference between the Rating of statistical capacity (0-100) of Overall level in 2008 and the Rating of statistical capacity (0-100) of Periodicity assessment in 2012?
Your answer should be very brief. -24.18. What is the difference between the Rating of statistical capacity (0-100) of Overall level in 2008 and the Rating of statistical capacity (0-100) of Source data assessment in 2012?
Your answer should be very brief. 0.03. What is the difference between the Rating of statistical capacity (0-100) in Periodicity assessment in 2008 and the Rating of statistical capacity (0-100) in Source data assessment in 2012?
Provide a short and direct response. 21.75. What is the difference between the Rating of statistical capacity (0-100) in Methodology assessment in 2009 and the Rating of statistical capacity (0-100) in Overall level in 2010?
Make the answer very short. -20.5. What is the difference between the Rating of statistical capacity (0-100) in Methodology assessment in 2009 and the Rating of statistical capacity (0-100) in Periodicity assessment in 2010?
Provide a short and direct response. -41.98. What is the difference between the Rating of statistical capacity (0-100) in Methodology assessment in 2009 and the Rating of statistical capacity (0-100) in Source data assessment in 2010?
Provide a succinct answer. -17.86. What is the difference between the Rating of statistical capacity (0-100) in Overall level in 2009 and the Rating of statistical capacity (0-100) in Periodicity assessment in 2010?
Your response must be concise. -23.15. What is the difference between the Rating of statistical capacity (0-100) of Overall level in 2009 and the Rating of statistical capacity (0-100) of Source data assessment in 2010?
Your answer should be very brief. 0.98. What is the difference between the Rating of statistical capacity (0-100) of Periodicity assessment in 2009 and the Rating of statistical capacity (0-100) of Source data assessment in 2010?
Your response must be concise. 22.46. What is the difference between the Rating of statistical capacity (0-100) in Methodology assessment in 2009 and the Rating of statistical capacity (0-100) in Overall level in 2011?
Keep it short and to the point. -21.27. What is the difference between the Rating of statistical capacity (0-100) of Methodology assessment in 2009 and the Rating of statistical capacity (0-100) of Periodicity assessment in 2011?
Keep it short and to the point. -43.1. What is the difference between the Rating of statistical capacity (0-100) in Methodology assessment in 2009 and the Rating of statistical capacity (0-100) in Source data assessment in 2011?
Your response must be concise. -18.1. What is the difference between the Rating of statistical capacity (0-100) in Overall level in 2009 and the Rating of statistical capacity (0-100) in Periodicity assessment in 2011?
Make the answer very short. -24.26. What is the difference between the Rating of statistical capacity (0-100) in Overall level in 2009 and the Rating of statistical capacity (0-100) in Source data assessment in 2011?
Your answer should be very brief. 0.74. What is the difference between the Rating of statistical capacity (0-100) in Periodicity assessment in 2009 and the Rating of statistical capacity (0-100) in Source data assessment in 2011?
Ensure brevity in your answer.  22.22. What is the difference between the Rating of statistical capacity (0-100) of Methodology assessment in 2009 and the Rating of statistical capacity (0-100) of Overall level in 2012?
Provide a succinct answer. -21.48. What is the difference between the Rating of statistical capacity (0-100) of Methodology assessment in 2009 and the Rating of statistical capacity (0-100) of Periodicity assessment in 2012?
Your response must be concise. -42.06. What is the difference between the Rating of statistical capacity (0-100) in Methodology assessment in 2009 and the Rating of statistical capacity (0-100) in Source data assessment in 2012?
Your response must be concise. -17.86. What is the difference between the Rating of statistical capacity (0-100) of Overall level in 2009 and the Rating of statistical capacity (0-100) of Periodicity assessment in 2012?
Your answer should be compact. -23.23. What is the difference between the Rating of statistical capacity (0-100) in Overall level in 2009 and the Rating of statistical capacity (0-100) in Source data assessment in 2012?
Keep it short and to the point. 0.98. What is the difference between the Rating of statistical capacity (0-100) in Periodicity assessment in 2009 and the Rating of statistical capacity (0-100) in Source data assessment in 2012?
Ensure brevity in your answer.  22.46. What is the difference between the Rating of statistical capacity (0-100) of Methodology assessment in 2010 and the Rating of statistical capacity (0-100) of Overall level in 2011?
Provide a short and direct response. -19.6. What is the difference between the Rating of statistical capacity (0-100) in Methodology assessment in 2010 and the Rating of statistical capacity (0-100) in Periodicity assessment in 2011?
Offer a terse response. -41.43. What is the difference between the Rating of statistical capacity (0-100) in Methodology assessment in 2010 and the Rating of statistical capacity (0-100) in Source data assessment in 2011?
Provide a short and direct response. -16.43. What is the difference between the Rating of statistical capacity (0-100) in Overall level in 2010 and the Rating of statistical capacity (0-100) in Periodicity assessment in 2011?
Keep it short and to the point. -22.59. What is the difference between the Rating of statistical capacity (0-100) of Overall level in 2010 and the Rating of statistical capacity (0-100) of Source data assessment in 2011?
Your answer should be very brief. 2.41. What is the difference between the Rating of statistical capacity (0-100) of Periodicity assessment in 2010 and the Rating of statistical capacity (0-100) of Source data assessment in 2011?
Your answer should be very brief. 23.89. What is the difference between the Rating of statistical capacity (0-100) in Methodology assessment in 2010 and the Rating of statistical capacity (0-100) in Overall level in 2012?
Your answer should be compact. -19.81. What is the difference between the Rating of statistical capacity (0-100) in Methodology assessment in 2010 and the Rating of statistical capacity (0-100) in Periodicity assessment in 2012?
Provide a short and direct response. -40.4. What is the difference between the Rating of statistical capacity (0-100) in Methodology assessment in 2010 and the Rating of statistical capacity (0-100) in Source data assessment in 2012?
Offer a terse response. -16.19. What is the difference between the Rating of statistical capacity (0-100) of Overall level in 2010 and the Rating of statistical capacity (0-100) of Periodicity assessment in 2012?
Make the answer very short. -21.56. What is the difference between the Rating of statistical capacity (0-100) in Overall level in 2010 and the Rating of statistical capacity (0-100) in Source data assessment in 2012?
Your answer should be compact. 2.65. What is the difference between the Rating of statistical capacity (0-100) of Periodicity assessment in 2010 and the Rating of statistical capacity (0-100) of Source data assessment in 2012?
Your answer should be very brief. 24.13. What is the difference between the Rating of statistical capacity (0-100) in Methodology assessment in 2011 and the Rating of statistical capacity (0-100) in Overall level in 2012?
Give a very brief answer. -18.86. What is the difference between the Rating of statistical capacity (0-100) of Methodology assessment in 2011 and the Rating of statistical capacity (0-100) of Periodicity assessment in 2012?
Provide a short and direct response. -39.44. What is the difference between the Rating of statistical capacity (0-100) in Methodology assessment in 2011 and the Rating of statistical capacity (0-100) in Source data assessment in 2012?
Give a very brief answer. -15.24. What is the difference between the Rating of statistical capacity (0-100) in Overall level in 2011 and the Rating of statistical capacity (0-100) in Periodicity assessment in 2012?
Provide a succinct answer. -20.79. What is the difference between the Rating of statistical capacity (0-100) in Overall level in 2011 and the Rating of statistical capacity (0-100) in Source data assessment in 2012?
Your response must be concise. 3.41. What is the difference between the Rating of statistical capacity (0-100) in Periodicity assessment in 2011 and the Rating of statistical capacity (0-100) in Source data assessment in 2012?
Offer a terse response. 25.24. What is the average Rating of statistical capacity (0-100) in Methodology assessment per year?
Offer a very short reply. 40.34. What is the average Rating of statistical capacity (0-100) in Overall level per year?
Give a very brief answer. 57.52. What is the average Rating of statistical capacity (0-100) of Periodicity assessment per year?
Your answer should be very brief. 78.9. What is the average Rating of statistical capacity (0-100) of Source data assessment per year?
Offer a very short reply. 53.31. In the year 2004, what is the difference between the Rating of statistical capacity (0-100) in Methodology assessment and Rating of statistical capacity (0-100) in Overall level?
Keep it short and to the point. -17.01. In the year 2004, what is the difference between the Rating of statistical capacity (0-100) in Methodology assessment and Rating of statistical capacity (0-100) in Periodicity assessment?
Your response must be concise. -37.94. In the year 2004, what is the difference between the Rating of statistical capacity (0-100) of Methodology assessment and Rating of statistical capacity (0-100) of Source data assessment?
Ensure brevity in your answer.  -13.1. In the year 2004, what is the difference between the Rating of statistical capacity (0-100) in Overall level and Rating of statistical capacity (0-100) in Periodicity assessment?
Offer a very short reply. -20.93. In the year 2004, what is the difference between the Rating of statistical capacity (0-100) of Overall level and Rating of statistical capacity (0-100) of Source data assessment?
Give a very brief answer. 3.92. In the year 2004, what is the difference between the Rating of statistical capacity (0-100) of Periodicity assessment and Rating of statistical capacity (0-100) of Source data assessment?
Offer a terse response. 24.84. In the year 2005, what is the difference between the Rating of statistical capacity (0-100) in Methodology assessment and Rating of statistical capacity (0-100) in Overall level?
Make the answer very short. -16.16. In the year 2005, what is the difference between the Rating of statistical capacity (0-100) in Methodology assessment and Rating of statistical capacity (0-100) in Periodicity assessment?
Ensure brevity in your answer.  -38.25. In the year 2005, what is the difference between the Rating of statistical capacity (0-100) in Methodology assessment and Rating of statistical capacity (0-100) in Source data assessment?
Offer a very short reply. -10.24. In the year 2005, what is the difference between the Rating of statistical capacity (0-100) of Overall level and Rating of statistical capacity (0-100) of Periodicity assessment?
Ensure brevity in your answer.  -22.09. In the year 2005, what is the difference between the Rating of statistical capacity (0-100) of Overall level and Rating of statistical capacity (0-100) of Source data assessment?
Provide a short and direct response. 5.93. In the year 2005, what is the difference between the Rating of statistical capacity (0-100) of Periodicity assessment and Rating of statistical capacity (0-100) of Source data assessment?
Give a very brief answer. 28.02. In the year 2006, what is the difference between the Rating of statistical capacity (0-100) in Methodology assessment and Rating of statistical capacity (0-100) in Overall level?
Ensure brevity in your answer.  -14.76. In the year 2006, what is the difference between the Rating of statistical capacity (0-100) in Methodology assessment and Rating of statistical capacity (0-100) in Periodicity assessment?
Provide a succinct answer. -35.71. In the year 2006, what is the difference between the Rating of statistical capacity (0-100) in Methodology assessment and Rating of statistical capacity (0-100) in Source data assessment?
Give a very brief answer. -8.57. In the year 2006, what is the difference between the Rating of statistical capacity (0-100) of Overall level and Rating of statistical capacity (0-100) of Periodicity assessment?
Your response must be concise. -20.95. In the year 2006, what is the difference between the Rating of statistical capacity (0-100) in Overall level and Rating of statistical capacity (0-100) in Source data assessment?
Provide a succinct answer. 6.19. In the year 2006, what is the difference between the Rating of statistical capacity (0-100) of Periodicity assessment and Rating of statistical capacity (0-100) of Source data assessment?
Ensure brevity in your answer.  27.14. In the year 2007, what is the difference between the Rating of statistical capacity (0-100) in Methodology assessment and Rating of statistical capacity (0-100) in Overall level?
Offer a very short reply. -15.45. In the year 2007, what is the difference between the Rating of statistical capacity (0-100) in Methodology assessment and Rating of statistical capacity (0-100) in Periodicity assessment?
Keep it short and to the point. -36.83. In the year 2007, what is the difference between the Rating of statistical capacity (0-100) of Methodology assessment and Rating of statistical capacity (0-100) of Source data assessment?
Your answer should be compact. -9.52. In the year 2007, what is the difference between the Rating of statistical capacity (0-100) of Overall level and Rating of statistical capacity (0-100) of Periodicity assessment?
Make the answer very short. -21.38. In the year 2007, what is the difference between the Rating of statistical capacity (0-100) of Overall level and Rating of statistical capacity (0-100) of Source data assessment?
Give a very brief answer. 5.93. In the year 2007, what is the difference between the Rating of statistical capacity (0-100) in Periodicity assessment and Rating of statistical capacity (0-100) in Source data assessment?
Ensure brevity in your answer.  27.3. In the year 2008, what is the difference between the Rating of statistical capacity (0-100) in Methodology assessment and Rating of statistical capacity (0-100) in Overall level?
Provide a short and direct response. -17.88. In the year 2008, what is the difference between the Rating of statistical capacity (0-100) in Methodology assessment and Rating of statistical capacity (0-100) in Periodicity assessment?
Provide a short and direct response. -39.6. In the year 2008, what is the difference between the Rating of statistical capacity (0-100) of Methodology assessment and Rating of statistical capacity (0-100) of Source data assessment?
Offer a terse response. -14.05. In the year 2008, what is the difference between the Rating of statistical capacity (0-100) in Overall level and Rating of statistical capacity (0-100) in Periodicity assessment?
Your response must be concise. -21.72. In the year 2008, what is the difference between the Rating of statistical capacity (0-100) of Overall level and Rating of statistical capacity (0-100) of Source data assessment?
Ensure brevity in your answer.  3.84. In the year 2008, what is the difference between the Rating of statistical capacity (0-100) of Periodicity assessment and Rating of statistical capacity (0-100) of Source data assessment?
Offer a terse response. 25.56. In the year 2009, what is the difference between the Rating of statistical capacity (0-100) in Methodology assessment and Rating of statistical capacity (0-100) in Overall level?
Give a very brief answer. -18.84. In the year 2009, what is the difference between the Rating of statistical capacity (0-100) of Methodology assessment and Rating of statistical capacity (0-100) of Periodicity assessment?
Offer a very short reply. -40.32. In the year 2009, what is the difference between the Rating of statistical capacity (0-100) in Methodology assessment and Rating of statistical capacity (0-100) in Source data assessment?
Make the answer very short. -16.19. In the year 2009, what is the difference between the Rating of statistical capacity (0-100) of Overall level and Rating of statistical capacity (0-100) of Periodicity assessment?
Offer a very short reply. -21.48. In the year 2009, what is the difference between the Rating of statistical capacity (0-100) of Overall level and Rating of statistical capacity (0-100) of Source data assessment?
Make the answer very short. 2.65. In the year 2009, what is the difference between the Rating of statistical capacity (0-100) of Periodicity assessment and Rating of statistical capacity (0-100) of Source data assessment?
Ensure brevity in your answer.  24.13. In the year 2010, what is the difference between the Rating of statistical capacity (0-100) of Methodology assessment and Rating of statistical capacity (0-100) of Overall level?
Provide a short and direct response. -18.84. In the year 2010, what is the difference between the Rating of statistical capacity (0-100) in Methodology assessment and Rating of statistical capacity (0-100) in Periodicity assessment?
Your answer should be very brief. -40.32. In the year 2010, what is the difference between the Rating of statistical capacity (0-100) in Methodology assessment and Rating of statistical capacity (0-100) in Source data assessment?
Make the answer very short. -16.19. In the year 2010, what is the difference between the Rating of statistical capacity (0-100) in Overall level and Rating of statistical capacity (0-100) in Periodicity assessment?
Provide a succinct answer. -21.48. In the year 2010, what is the difference between the Rating of statistical capacity (0-100) of Overall level and Rating of statistical capacity (0-100) of Source data assessment?
Provide a short and direct response. 2.65. In the year 2010, what is the difference between the Rating of statistical capacity (0-100) of Periodicity assessment and Rating of statistical capacity (0-100) of Source data assessment?
Keep it short and to the point. 24.13. In the year 2011, what is the difference between the Rating of statistical capacity (0-100) of Methodology assessment and Rating of statistical capacity (0-100) of Overall level?
Offer a very short reply. -18.65. In the year 2011, what is the difference between the Rating of statistical capacity (0-100) in Methodology assessment and Rating of statistical capacity (0-100) in Periodicity assessment?
Your response must be concise. -40.48. In the year 2011, what is the difference between the Rating of statistical capacity (0-100) of Methodology assessment and Rating of statistical capacity (0-100) of Source data assessment?
Keep it short and to the point. -15.48. In the year 2011, what is the difference between the Rating of statistical capacity (0-100) in Overall level and Rating of statistical capacity (0-100) in Periodicity assessment?
Provide a succinct answer. -21.83. In the year 2011, what is the difference between the Rating of statistical capacity (0-100) in Overall level and Rating of statistical capacity (0-100) in Source data assessment?
Your answer should be very brief. 3.17. In the year 2012, what is the difference between the Rating of statistical capacity (0-100) of Methodology assessment and Rating of statistical capacity (0-100) of Overall level?
Give a very brief answer. -16.96. In the year 2012, what is the difference between the Rating of statistical capacity (0-100) in Methodology assessment and Rating of statistical capacity (0-100) in Periodicity assessment?
Offer a terse response. -37.54. In the year 2012, what is the difference between the Rating of statistical capacity (0-100) of Methodology assessment and Rating of statistical capacity (0-100) of Source data assessment?
Make the answer very short. -13.33. In the year 2012, what is the difference between the Rating of statistical capacity (0-100) in Overall level and Rating of statistical capacity (0-100) in Periodicity assessment?
Give a very brief answer. -20.58. In the year 2012, what is the difference between the Rating of statistical capacity (0-100) of Overall level and Rating of statistical capacity (0-100) of Source data assessment?
Your answer should be compact. 3.62. In the year 2012, what is the difference between the Rating of statistical capacity (0-100) in Periodicity assessment and Rating of statistical capacity (0-100) in Source data assessment?
Provide a succinct answer. 24.21. What is the ratio of the Rating of statistical capacity (0-100) of Methodology assessment in 2004 to that in 2005?
Provide a short and direct response. 0.96. What is the ratio of the Rating of statistical capacity (0-100) of Overall level in 2004 to that in 2005?
Provide a short and direct response. 0.99. What is the ratio of the Rating of statistical capacity (0-100) in Periodicity assessment in 2004 to that in 2005?
Provide a succinct answer. 0.97. What is the ratio of the Rating of statistical capacity (0-100) of Source data assessment in 2004 to that in 2005?
Provide a short and direct response. 1.02. What is the ratio of the Rating of statistical capacity (0-100) of Methodology assessment in 2004 to that in 2006?
Your answer should be compact. 0.92. What is the ratio of the Rating of statistical capacity (0-100) in Overall level in 2004 to that in 2006?
Ensure brevity in your answer.  0.98. What is the ratio of the Rating of statistical capacity (0-100) in Periodicity assessment in 2004 to that in 2006?
Ensure brevity in your answer.  0.98. What is the ratio of the Rating of statistical capacity (0-100) of Source data assessment in 2004 to that in 2006?
Your response must be concise. 1.02. What is the ratio of the Rating of statistical capacity (0-100) of Methodology assessment in 2004 to that in 2007?
Offer a very short reply. 0.93. What is the ratio of the Rating of statistical capacity (0-100) in Overall level in 2004 to that in 2007?
Keep it short and to the point. 0.97. What is the ratio of the Rating of statistical capacity (0-100) in Periodicity assessment in 2004 to that in 2007?
Provide a succinct answer. 0.97. What is the ratio of the Rating of statistical capacity (0-100) in Source data assessment in 2004 to that in 2007?
Keep it short and to the point. 1.01. What is the ratio of the Rating of statistical capacity (0-100) in Overall level in 2004 to that in 2008?
Your answer should be very brief. 0.99. What is the ratio of the Rating of statistical capacity (0-100) of Periodicity assessment in 2004 to that in 2008?
Your answer should be very brief. 0.98. What is the ratio of the Rating of statistical capacity (0-100) of Source data assessment in 2004 to that in 2008?
Your response must be concise. 0.99. What is the ratio of the Rating of statistical capacity (0-100) of Methodology assessment in 2004 to that in 2009?
Provide a succinct answer. 1.01. What is the ratio of the Rating of statistical capacity (0-100) in Overall level in 2004 to that in 2009?
Your response must be concise. 0.97. What is the ratio of the Rating of statistical capacity (0-100) in Periodicity assessment in 2004 to that in 2009?
Your response must be concise. 0.97. What is the ratio of the Rating of statistical capacity (0-100) of Source data assessment in 2004 to that in 2009?
Ensure brevity in your answer.  0.95. What is the ratio of the Rating of statistical capacity (0-100) in Methodology assessment in 2004 to that in 2010?
Provide a short and direct response. 0.96. What is the ratio of the Rating of statistical capacity (0-100) of Overall level in 2004 to that in 2010?
Offer a terse response. 0.94. What is the ratio of the Rating of statistical capacity (0-100) of Periodicity assessment in 2004 to that in 2010?
Make the answer very short. 0.95. What is the ratio of the Rating of statistical capacity (0-100) in Source data assessment in 2004 to that in 2010?
Your answer should be very brief. 0.92. What is the ratio of the Rating of statistical capacity (0-100) of Methodology assessment in 2004 to that in 2011?
Your answer should be very brief. 0.94. What is the ratio of the Rating of statistical capacity (0-100) of Overall level in 2004 to that in 2011?
Your response must be concise. 0.93. What is the ratio of the Rating of statistical capacity (0-100) of Periodicity assessment in 2004 to that in 2011?
Ensure brevity in your answer.  0.94. What is the ratio of the Rating of statistical capacity (0-100) of Source data assessment in 2004 to that in 2011?
Give a very brief answer. 0.92. What is the ratio of the Rating of statistical capacity (0-100) in Overall level in 2004 to that in 2012?
Provide a short and direct response. 0.93. What is the ratio of the Rating of statistical capacity (0-100) in Periodicity assessment in 2004 to that in 2012?
Give a very brief answer. 0.95. What is the ratio of the Rating of statistical capacity (0-100) of Source data assessment in 2004 to that in 2012?
Offer a terse response. 0.92. What is the ratio of the Rating of statistical capacity (0-100) of Methodology assessment in 2005 to that in 2006?
Ensure brevity in your answer.  0.95. What is the ratio of the Rating of statistical capacity (0-100) in Overall level in 2005 to that in 2006?
Ensure brevity in your answer.  0.99. What is the ratio of the Rating of statistical capacity (0-100) in Periodicity assessment in 2005 to that in 2006?
Offer a very short reply. 1.01. What is the ratio of the Rating of statistical capacity (0-100) of Methodology assessment in 2005 to that in 2007?
Your answer should be compact. 0.97. What is the ratio of the Rating of statistical capacity (0-100) of Overall level in 2005 to that in 2007?
Provide a short and direct response. 0.99. What is the ratio of the Rating of statistical capacity (0-100) in Periodicity assessment in 2005 to that in 2007?
Give a very brief answer. 1. What is the ratio of the Rating of statistical capacity (0-100) of Source data assessment in 2005 to that in 2007?
Your answer should be compact. 0.99. What is the ratio of the Rating of statistical capacity (0-100) of Methodology assessment in 2005 to that in 2008?
Make the answer very short. 1.05. What is the ratio of the Rating of statistical capacity (0-100) in Periodicity assessment in 2005 to that in 2008?
Your answer should be compact. 1.01. What is the ratio of the Rating of statistical capacity (0-100) of Source data assessment in 2005 to that in 2008?
Keep it short and to the point. 0.96. What is the ratio of the Rating of statistical capacity (0-100) in Methodology assessment in 2005 to that in 2009?
Your response must be concise. 1.05. What is the ratio of the Rating of statistical capacity (0-100) in Overall level in 2005 to that in 2009?
Ensure brevity in your answer.  0.99. What is the ratio of the Rating of statistical capacity (0-100) in Source data assessment in 2005 to that in 2009?
Provide a succinct answer. 0.93. What is the ratio of the Rating of statistical capacity (0-100) in Methodology assessment in 2005 to that in 2010?
Offer a terse response. 1.01. What is the ratio of the Rating of statistical capacity (0-100) of Overall level in 2005 to that in 2010?
Ensure brevity in your answer.  0.96. What is the ratio of the Rating of statistical capacity (0-100) in Periodicity assessment in 2005 to that in 2010?
Your response must be concise. 0.98. What is the ratio of the Rating of statistical capacity (0-100) in Source data assessment in 2005 to that in 2010?
Keep it short and to the point. 0.9. What is the ratio of the Rating of statistical capacity (0-100) of Methodology assessment in 2005 to that in 2011?
Offer a very short reply. 0.98. What is the ratio of the Rating of statistical capacity (0-100) in Overall level in 2005 to that in 2011?
Make the answer very short. 0.95. What is the ratio of the Rating of statistical capacity (0-100) of Periodicity assessment in 2005 to that in 2011?
Keep it short and to the point. 0.96. What is the ratio of the Rating of statistical capacity (0-100) in Source data assessment in 2005 to that in 2011?
Offer a terse response. 0.89. What is the ratio of the Rating of statistical capacity (0-100) in Methodology assessment in 2005 to that in 2012?
Make the answer very short. 0.94. What is the ratio of the Rating of statistical capacity (0-100) in Overall level in 2005 to that in 2012?
Keep it short and to the point. 0.94. What is the ratio of the Rating of statistical capacity (0-100) in Periodicity assessment in 2005 to that in 2012?
Give a very brief answer. 0.98. What is the ratio of the Rating of statistical capacity (0-100) in Source data assessment in 2005 to that in 2012?
Your answer should be very brief. 0.9. What is the ratio of the Rating of statistical capacity (0-100) of Methodology assessment in 2006 to that in 2007?
Your response must be concise. 1.01. What is the ratio of the Rating of statistical capacity (0-100) of Overall level in 2006 to that in 2007?
Keep it short and to the point. 1. What is the ratio of the Rating of statistical capacity (0-100) of Periodicity assessment in 2006 to that in 2007?
Provide a short and direct response. 0.99. What is the ratio of the Rating of statistical capacity (0-100) of Methodology assessment in 2006 to that in 2008?
Your answer should be compact. 1.1. What is the ratio of the Rating of statistical capacity (0-100) in Overall level in 2006 to that in 2008?
Your answer should be very brief. 1.01. What is the ratio of the Rating of statistical capacity (0-100) in Source data assessment in 2006 to that in 2008?
Your answer should be very brief. 0.97. What is the ratio of the Rating of statistical capacity (0-100) in Methodology assessment in 2006 to that in 2009?
Provide a short and direct response. 1.1. What is the ratio of the Rating of statistical capacity (0-100) of Overall level in 2006 to that in 2009?
Ensure brevity in your answer.  1. What is the ratio of the Rating of statistical capacity (0-100) in Source data assessment in 2006 to that in 2009?
Give a very brief answer. 0.93. What is the ratio of the Rating of statistical capacity (0-100) of Methodology assessment in 2006 to that in 2010?
Offer a terse response. 1.05. What is the ratio of the Rating of statistical capacity (0-100) of Overall level in 2006 to that in 2010?
Provide a short and direct response. 0.97. What is the ratio of the Rating of statistical capacity (0-100) of Periodicity assessment in 2006 to that in 2010?
Your response must be concise. 0.97. What is the ratio of the Rating of statistical capacity (0-100) in Source data assessment in 2006 to that in 2010?
Offer a terse response. 0.9. What is the ratio of the Rating of statistical capacity (0-100) of Methodology assessment in 2006 to that in 2011?
Provide a succinct answer. 1.03. What is the ratio of the Rating of statistical capacity (0-100) in Overall level in 2006 to that in 2011?
Provide a succinct answer. 0.95. What is the ratio of the Rating of statistical capacity (0-100) of Periodicity assessment in 2006 to that in 2011?
Ensure brevity in your answer.  0.96. What is the ratio of the Rating of statistical capacity (0-100) of Source data assessment in 2006 to that in 2011?
Provide a succinct answer. 0.9. What is the ratio of the Rating of statistical capacity (0-100) of Methodology assessment in 2006 to that in 2012?
Your response must be concise. 0.98. What is the ratio of the Rating of statistical capacity (0-100) of Overall level in 2006 to that in 2012?
Offer a terse response. 0.95. What is the ratio of the Rating of statistical capacity (0-100) of Periodicity assessment in 2006 to that in 2012?
Offer a very short reply. 0.97. What is the ratio of the Rating of statistical capacity (0-100) of Source data assessment in 2006 to that in 2012?
Provide a short and direct response. 0.9. What is the ratio of the Rating of statistical capacity (0-100) in Methodology assessment in 2007 to that in 2008?
Make the answer very short. 1.09. What is the ratio of the Rating of statistical capacity (0-100) in Overall level in 2007 to that in 2008?
Your response must be concise. 1.02. What is the ratio of the Rating of statistical capacity (0-100) in Periodicity assessment in 2007 to that in 2008?
Offer a very short reply. 1.01. What is the ratio of the Rating of statistical capacity (0-100) of Source data assessment in 2007 to that in 2008?
Ensure brevity in your answer.  0.98. What is the ratio of the Rating of statistical capacity (0-100) in Methodology assessment in 2007 to that in 2009?
Your answer should be very brief. 1.09. What is the ratio of the Rating of statistical capacity (0-100) of Overall level in 2007 to that in 2009?
Offer a terse response. 1. What is the ratio of the Rating of statistical capacity (0-100) of Periodicity assessment in 2007 to that in 2009?
Your response must be concise. 1. What is the ratio of the Rating of statistical capacity (0-100) in Source data assessment in 2007 to that in 2009?
Give a very brief answer. 0.94. What is the ratio of the Rating of statistical capacity (0-100) in Methodology assessment in 2007 to that in 2010?
Offer a terse response. 1.04. What is the ratio of the Rating of statistical capacity (0-100) in Overall level in 2007 to that in 2010?
Keep it short and to the point. 0.97. What is the ratio of the Rating of statistical capacity (0-100) of Periodicity assessment in 2007 to that in 2010?
Your answer should be compact. 0.98. What is the ratio of the Rating of statistical capacity (0-100) of Source data assessment in 2007 to that in 2010?
Your response must be concise. 0.91. What is the ratio of the Rating of statistical capacity (0-100) of Methodology assessment in 2007 to that in 2011?
Offer a very short reply. 1.02. What is the ratio of the Rating of statistical capacity (0-100) in Periodicity assessment in 2007 to that in 2011?
Your answer should be very brief. 0.96. What is the ratio of the Rating of statistical capacity (0-100) in Source data assessment in 2007 to that in 2011?
Provide a short and direct response. 0.91. What is the ratio of the Rating of statistical capacity (0-100) of Methodology assessment in 2007 to that in 2012?
Your response must be concise. 0.97. What is the ratio of the Rating of statistical capacity (0-100) of Overall level in 2007 to that in 2012?
Keep it short and to the point. 0.95. What is the ratio of the Rating of statistical capacity (0-100) in Periodicity assessment in 2007 to that in 2012?
Your answer should be very brief. 0.98. What is the ratio of the Rating of statistical capacity (0-100) in Source data assessment in 2007 to that in 2012?
Your answer should be very brief. 0.91. What is the ratio of the Rating of statistical capacity (0-100) of Overall level in 2008 to that in 2009?
Ensure brevity in your answer.  0.98. What is the ratio of the Rating of statistical capacity (0-100) of Periodicity assessment in 2008 to that in 2009?
Your answer should be very brief. 0.99. What is the ratio of the Rating of statistical capacity (0-100) in Source data assessment in 2008 to that in 2009?
Your response must be concise. 0.96. What is the ratio of the Rating of statistical capacity (0-100) in Overall level in 2008 to that in 2010?
Offer a terse response. 0.96. What is the ratio of the Rating of statistical capacity (0-100) in Periodicity assessment in 2008 to that in 2010?
Your answer should be very brief. 0.97. What is the ratio of the Rating of statistical capacity (0-100) in Source data assessment in 2008 to that in 2010?
Give a very brief answer. 0.93. What is the ratio of the Rating of statistical capacity (0-100) of Methodology assessment in 2008 to that in 2011?
Offer a terse response. 0.94. What is the ratio of the Rating of statistical capacity (0-100) in Overall level in 2008 to that in 2011?
Offer a terse response. 0.94. What is the ratio of the Rating of statistical capacity (0-100) of Periodicity assessment in 2008 to that in 2011?
Your response must be concise. 0.96. What is the ratio of the Rating of statistical capacity (0-100) in Source data assessment in 2008 to that in 2011?
Provide a short and direct response. 0.93. What is the ratio of the Rating of statistical capacity (0-100) of Methodology assessment in 2008 to that in 2012?
Give a very brief answer. 0.89. What is the ratio of the Rating of statistical capacity (0-100) of Overall level in 2008 to that in 2012?
Your answer should be very brief. 0.94. What is the ratio of the Rating of statistical capacity (0-100) in Periodicity assessment in 2008 to that in 2012?
Your answer should be compact. 0.97. What is the ratio of the Rating of statistical capacity (0-100) in Source data assessment in 2008 to that in 2012?
Your answer should be very brief. 0.93. What is the ratio of the Rating of statistical capacity (0-100) in Methodology assessment in 2009 to that in 2010?
Offer a terse response. 0.96. What is the ratio of the Rating of statistical capacity (0-100) of Overall level in 2009 to that in 2010?
Offer a terse response. 0.97. What is the ratio of the Rating of statistical capacity (0-100) of Periodicity assessment in 2009 to that in 2010?
Your answer should be compact. 0.98. What is the ratio of the Rating of statistical capacity (0-100) in Source data assessment in 2009 to that in 2010?
Give a very brief answer. 0.97. What is the ratio of the Rating of statistical capacity (0-100) in Methodology assessment in 2009 to that in 2011?
Offer a terse response. 0.94. What is the ratio of the Rating of statistical capacity (0-100) of Overall level in 2009 to that in 2011?
Keep it short and to the point. 0.96. What is the ratio of the Rating of statistical capacity (0-100) of Periodicity assessment in 2009 to that in 2011?
Your response must be concise. 0.97. What is the ratio of the Rating of statistical capacity (0-100) in Source data assessment in 2009 to that in 2011?
Make the answer very short. 0.97. What is the ratio of the Rating of statistical capacity (0-100) of Methodology assessment in 2009 to that in 2012?
Offer a terse response. 0.89. What is the ratio of the Rating of statistical capacity (0-100) in Overall level in 2009 to that in 2012?
Keep it short and to the point. 0.96. What is the ratio of the Rating of statistical capacity (0-100) of Periodicity assessment in 2009 to that in 2012?
Offer a very short reply. 0.98. What is the ratio of the Rating of statistical capacity (0-100) of Source data assessment in 2009 to that in 2012?
Keep it short and to the point. 0.97. What is the ratio of the Rating of statistical capacity (0-100) of Methodology assessment in 2010 to that in 2011?
Give a very brief answer. 0.98. What is the ratio of the Rating of statistical capacity (0-100) of Overall level in 2010 to that in 2011?
Make the answer very short. 0.99. What is the ratio of the Rating of statistical capacity (0-100) in Periodicity assessment in 2010 to that in 2011?
Keep it short and to the point. 0.99. What is the ratio of the Rating of statistical capacity (0-100) of Methodology assessment in 2010 to that in 2012?
Offer a very short reply. 0.93. What is the ratio of the Rating of statistical capacity (0-100) of Overall level in 2010 to that in 2012?
Your answer should be very brief. 0.98. What is the ratio of the Rating of statistical capacity (0-100) in Periodicity assessment in 2010 to that in 2012?
Your answer should be very brief. 1. What is the ratio of the Rating of statistical capacity (0-100) of Methodology assessment in 2011 to that in 2012?
Keep it short and to the point. 0.96. What is the ratio of the Rating of statistical capacity (0-100) of Periodicity assessment in 2011 to that in 2012?
Your response must be concise. 1.01. What is the ratio of the Rating of statistical capacity (0-100) of Source data assessment in 2011 to that in 2012?
Your answer should be very brief. 1. What is the difference between the highest and the second highest Rating of statistical capacity (0-100) of Methodology assessment?
Offer a very short reply. 0.71. What is the difference between the highest and the second highest Rating of statistical capacity (0-100) in Overall level?
Provide a succinct answer. 0.21. What is the difference between the highest and the second highest Rating of statistical capacity (0-100) in Periodicity assessment?
Provide a succinct answer. 1.03. What is the difference between the highest and the second highest Rating of statistical capacity (0-100) in Source data assessment?
Offer a terse response. 0.24. What is the difference between the highest and the lowest Rating of statistical capacity (0-100) in Methodology assessment?
Ensure brevity in your answer.  4.52. What is the difference between the highest and the lowest Rating of statistical capacity (0-100) of Overall level?
Your response must be concise. 4.23. What is the difference between the highest and the lowest Rating of statistical capacity (0-100) of Periodicity assessment?
Make the answer very short. 4.92. What is the difference between the highest and the lowest Rating of statistical capacity (0-100) of Source data assessment?
Keep it short and to the point. 5.95. 